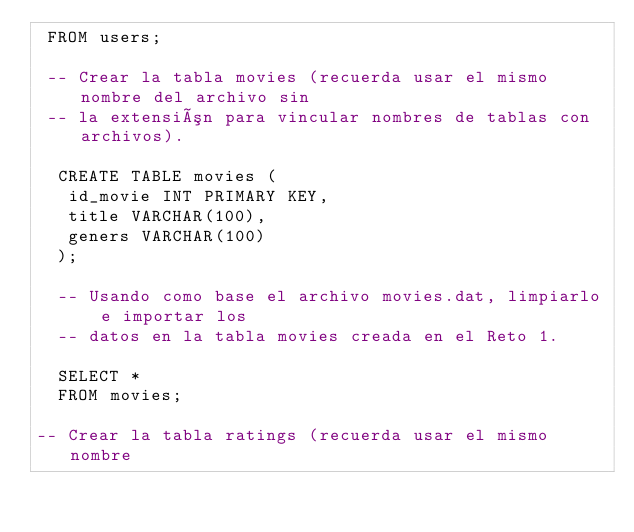<code> <loc_0><loc_0><loc_500><loc_500><_SQL_> FROM users;
  
 -- Crear la tabla movies (recuerda usar el mismo nombre del archivo sin 
 -- la extensión para vincular nombres de tablas con archivos).
 
  CREATE TABLE movies (
   id_movie INT PRIMARY KEY,
   title VARCHAR(100),
   geners VARCHAR(100)
  );
  
  -- Usando como base el archivo movies.dat, limpiarlo e importar los 
  -- datos en la tabla movies creada en el Reto 1.

  SELECT *
  FROM movies;
  
-- Crear la tabla ratings (recuerda usar el mismo nombre </code> 